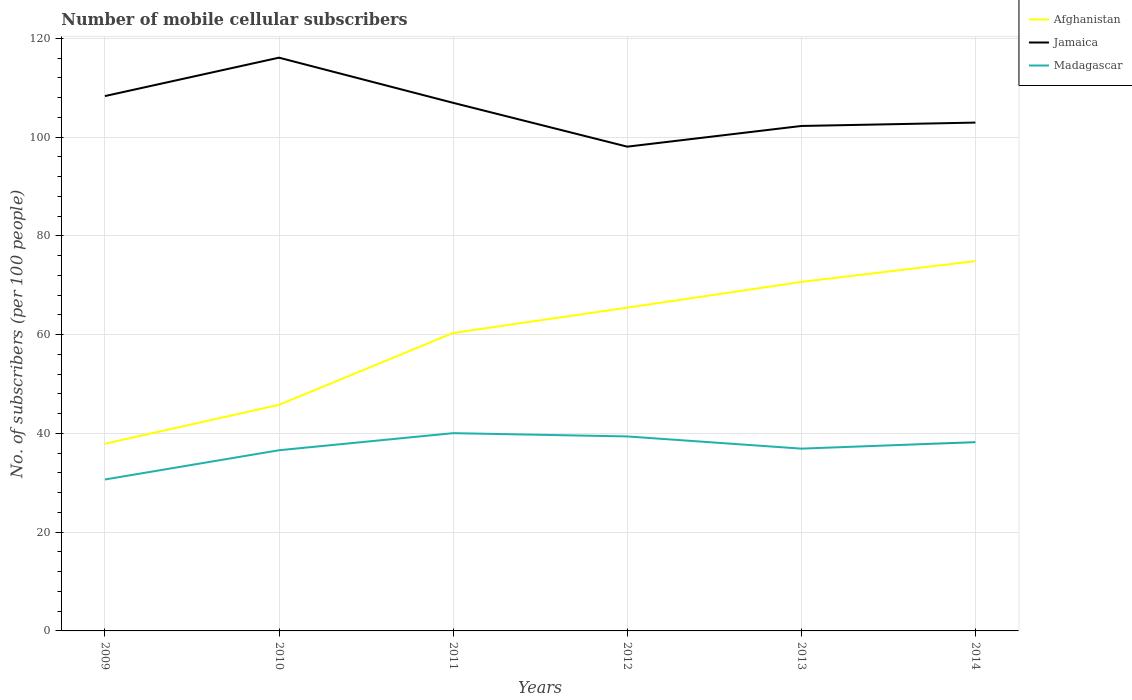Across all years, what is the maximum number of mobile cellular subscribers in Afghanistan?
Give a very brief answer. 37.89. What is the total number of mobile cellular subscribers in Madagascar in the graph?
Offer a very short reply. 3.13. What is the difference between the highest and the second highest number of mobile cellular subscribers in Madagascar?
Your answer should be very brief. 9.38. What is the difference between the highest and the lowest number of mobile cellular subscribers in Madagascar?
Offer a terse response. 3. What is the difference between two consecutive major ticks on the Y-axis?
Provide a short and direct response. 20. Are the values on the major ticks of Y-axis written in scientific E-notation?
Your answer should be very brief. No. Does the graph contain any zero values?
Give a very brief answer. No. Where does the legend appear in the graph?
Give a very brief answer. Top right. How many legend labels are there?
Give a very brief answer. 3. How are the legend labels stacked?
Provide a short and direct response. Vertical. What is the title of the graph?
Your response must be concise. Number of mobile cellular subscribers. What is the label or title of the X-axis?
Provide a succinct answer. Years. What is the label or title of the Y-axis?
Give a very brief answer. No. of subscribers (per 100 people). What is the No. of subscribers (per 100 people) of Afghanistan in 2009?
Offer a very short reply. 37.89. What is the No. of subscribers (per 100 people) of Jamaica in 2009?
Provide a succinct answer. 108.29. What is the No. of subscribers (per 100 people) in Madagascar in 2009?
Your answer should be compact. 30.66. What is the No. of subscribers (per 100 people) in Afghanistan in 2010?
Give a very brief answer. 45.78. What is the No. of subscribers (per 100 people) of Jamaica in 2010?
Your answer should be very brief. 116.07. What is the No. of subscribers (per 100 people) in Madagascar in 2010?
Your response must be concise. 36.58. What is the No. of subscribers (per 100 people) in Afghanistan in 2011?
Provide a succinct answer. 60.33. What is the No. of subscribers (per 100 people) of Jamaica in 2011?
Keep it short and to the point. 106.92. What is the No. of subscribers (per 100 people) of Madagascar in 2011?
Your answer should be very brief. 40.04. What is the No. of subscribers (per 100 people) of Afghanistan in 2012?
Keep it short and to the point. 65.45. What is the No. of subscribers (per 100 people) of Jamaica in 2012?
Make the answer very short. 98.05. What is the No. of subscribers (per 100 people) of Madagascar in 2012?
Provide a short and direct response. 39.38. What is the No. of subscribers (per 100 people) of Afghanistan in 2013?
Give a very brief answer. 70.66. What is the No. of subscribers (per 100 people) of Jamaica in 2013?
Give a very brief answer. 102.24. What is the No. of subscribers (per 100 people) of Madagascar in 2013?
Offer a very short reply. 36.91. What is the No. of subscribers (per 100 people) in Afghanistan in 2014?
Offer a very short reply. 74.88. What is the No. of subscribers (per 100 people) in Jamaica in 2014?
Offer a very short reply. 102.92. What is the No. of subscribers (per 100 people) of Madagascar in 2014?
Your answer should be very brief. 38.22. Across all years, what is the maximum No. of subscribers (per 100 people) in Afghanistan?
Keep it short and to the point. 74.88. Across all years, what is the maximum No. of subscribers (per 100 people) in Jamaica?
Provide a short and direct response. 116.07. Across all years, what is the maximum No. of subscribers (per 100 people) in Madagascar?
Make the answer very short. 40.04. Across all years, what is the minimum No. of subscribers (per 100 people) in Afghanistan?
Your answer should be very brief. 37.89. Across all years, what is the minimum No. of subscribers (per 100 people) of Jamaica?
Make the answer very short. 98.05. Across all years, what is the minimum No. of subscribers (per 100 people) in Madagascar?
Offer a terse response. 30.66. What is the total No. of subscribers (per 100 people) in Afghanistan in the graph?
Keep it short and to the point. 355. What is the total No. of subscribers (per 100 people) of Jamaica in the graph?
Provide a succinct answer. 634.49. What is the total No. of subscribers (per 100 people) in Madagascar in the graph?
Your answer should be compact. 221.79. What is the difference between the No. of subscribers (per 100 people) in Afghanistan in 2009 and that in 2010?
Make the answer very short. -7.88. What is the difference between the No. of subscribers (per 100 people) of Jamaica in 2009 and that in 2010?
Keep it short and to the point. -7.77. What is the difference between the No. of subscribers (per 100 people) of Madagascar in 2009 and that in 2010?
Offer a very short reply. -5.92. What is the difference between the No. of subscribers (per 100 people) in Afghanistan in 2009 and that in 2011?
Provide a succinct answer. -22.43. What is the difference between the No. of subscribers (per 100 people) of Jamaica in 2009 and that in 2011?
Your response must be concise. 1.37. What is the difference between the No. of subscribers (per 100 people) in Madagascar in 2009 and that in 2011?
Your answer should be very brief. -9.38. What is the difference between the No. of subscribers (per 100 people) in Afghanistan in 2009 and that in 2012?
Keep it short and to the point. -27.56. What is the difference between the No. of subscribers (per 100 people) of Jamaica in 2009 and that in 2012?
Keep it short and to the point. 10.24. What is the difference between the No. of subscribers (per 100 people) in Madagascar in 2009 and that in 2012?
Your answer should be very brief. -8.72. What is the difference between the No. of subscribers (per 100 people) of Afghanistan in 2009 and that in 2013?
Your answer should be compact. -32.77. What is the difference between the No. of subscribers (per 100 people) of Jamaica in 2009 and that in 2013?
Keep it short and to the point. 6.06. What is the difference between the No. of subscribers (per 100 people) in Madagascar in 2009 and that in 2013?
Offer a very short reply. -6.25. What is the difference between the No. of subscribers (per 100 people) in Afghanistan in 2009 and that in 2014?
Keep it short and to the point. -36.99. What is the difference between the No. of subscribers (per 100 people) in Jamaica in 2009 and that in 2014?
Provide a succinct answer. 5.37. What is the difference between the No. of subscribers (per 100 people) in Madagascar in 2009 and that in 2014?
Keep it short and to the point. -7.56. What is the difference between the No. of subscribers (per 100 people) of Afghanistan in 2010 and that in 2011?
Your response must be concise. -14.55. What is the difference between the No. of subscribers (per 100 people) in Jamaica in 2010 and that in 2011?
Ensure brevity in your answer.  9.14. What is the difference between the No. of subscribers (per 100 people) in Madagascar in 2010 and that in 2011?
Give a very brief answer. -3.46. What is the difference between the No. of subscribers (per 100 people) in Afghanistan in 2010 and that in 2012?
Offer a terse response. -19.67. What is the difference between the No. of subscribers (per 100 people) in Jamaica in 2010 and that in 2012?
Give a very brief answer. 18.02. What is the difference between the No. of subscribers (per 100 people) of Madagascar in 2010 and that in 2012?
Provide a succinct answer. -2.79. What is the difference between the No. of subscribers (per 100 people) in Afghanistan in 2010 and that in 2013?
Keep it short and to the point. -24.88. What is the difference between the No. of subscribers (per 100 people) in Jamaica in 2010 and that in 2013?
Make the answer very short. 13.83. What is the difference between the No. of subscribers (per 100 people) of Madagascar in 2010 and that in 2013?
Provide a short and direct response. -0.32. What is the difference between the No. of subscribers (per 100 people) of Afghanistan in 2010 and that in 2014?
Offer a terse response. -29.1. What is the difference between the No. of subscribers (per 100 people) in Jamaica in 2010 and that in 2014?
Your answer should be very brief. 13.15. What is the difference between the No. of subscribers (per 100 people) of Madagascar in 2010 and that in 2014?
Your response must be concise. -1.64. What is the difference between the No. of subscribers (per 100 people) of Afghanistan in 2011 and that in 2012?
Give a very brief answer. -5.13. What is the difference between the No. of subscribers (per 100 people) of Jamaica in 2011 and that in 2012?
Your answer should be compact. 8.87. What is the difference between the No. of subscribers (per 100 people) of Madagascar in 2011 and that in 2012?
Your response must be concise. 0.67. What is the difference between the No. of subscribers (per 100 people) of Afghanistan in 2011 and that in 2013?
Make the answer very short. -10.34. What is the difference between the No. of subscribers (per 100 people) in Jamaica in 2011 and that in 2013?
Offer a terse response. 4.69. What is the difference between the No. of subscribers (per 100 people) of Madagascar in 2011 and that in 2013?
Ensure brevity in your answer.  3.13. What is the difference between the No. of subscribers (per 100 people) in Afghanistan in 2011 and that in 2014?
Your answer should be compact. -14.56. What is the difference between the No. of subscribers (per 100 people) of Jamaica in 2011 and that in 2014?
Your answer should be very brief. 4. What is the difference between the No. of subscribers (per 100 people) of Madagascar in 2011 and that in 2014?
Provide a succinct answer. 1.82. What is the difference between the No. of subscribers (per 100 people) in Afghanistan in 2012 and that in 2013?
Offer a terse response. -5.21. What is the difference between the No. of subscribers (per 100 people) in Jamaica in 2012 and that in 2013?
Give a very brief answer. -4.19. What is the difference between the No. of subscribers (per 100 people) of Madagascar in 2012 and that in 2013?
Your response must be concise. 2.47. What is the difference between the No. of subscribers (per 100 people) in Afghanistan in 2012 and that in 2014?
Your answer should be compact. -9.43. What is the difference between the No. of subscribers (per 100 people) of Jamaica in 2012 and that in 2014?
Your answer should be very brief. -4.87. What is the difference between the No. of subscribers (per 100 people) of Madagascar in 2012 and that in 2014?
Offer a very short reply. 1.16. What is the difference between the No. of subscribers (per 100 people) of Afghanistan in 2013 and that in 2014?
Your answer should be very brief. -4.22. What is the difference between the No. of subscribers (per 100 people) of Jamaica in 2013 and that in 2014?
Keep it short and to the point. -0.68. What is the difference between the No. of subscribers (per 100 people) in Madagascar in 2013 and that in 2014?
Offer a terse response. -1.31. What is the difference between the No. of subscribers (per 100 people) of Afghanistan in 2009 and the No. of subscribers (per 100 people) of Jamaica in 2010?
Keep it short and to the point. -78.17. What is the difference between the No. of subscribers (per 100 people) of Afghanistan in 2009 and the No. of subscribers (per 100 people) of Madagascar in 2010?
Offer a very short reply. 1.31. What is the difference between the No. of subscribers (per 100 people) in Jamaica in 2009 and the No. of subscribers (per 100 people) in Madagascar in 2010?
Offer a very short reply. 71.71. What is the difference between the No. of subscribers (per 100 people) of Afghanistan in 2009 and the No. of subscribers (per 100 people) of Jamaica in 2011?
Your answer should be compact. -69.03. What is the difference between the No. of subscribers (per 100 people) of Afghanistan in 2009 and the No. of subscribers (per 100 people) of Madagascar in 2011?
Keep it short and to the point. -2.15. What is the difference between the No. of subscribers (per 100 people) in Jamaica in 2009 and the No. of subscribers (per 100 people) in Madagascar in 2011?
Keep it short and to the point. 68.25. What is the difference between the No. of subscribers (per 100 people) in Afghanistan in 2009 and the No. of subscribers (per 100 people) in Jamaica in 2012?
Keep it short and to the point. -60.15. What is the difference between the No. of subscribers (per 100 people) in Afghanistan in 2009 and the No. of subscribers (per 100 people) in Madagascar in 2012?
Your response must be concise. -1.48. What is the difference between the No. of subscribers (per 100 people) in Jamaica in 2009 and the No. of subscribers (per 100 people) in Madagascar in 2012?
Provide a succinct answer. 68.92. What is the difference between the No. of subscribers (per 100 people) of Afghanistan in 2009 and the No. of subscribers (per 100 people) of Jamaica in 2013?
Your answer should be compact. -64.34. What is the difference between the No. of subscribers (per 100 people) of Afghanistan in 2009 and the No. of subscribers (per 100 people) of Madagascar in 2013?
Your response must be concise. 0.99. What is the difference between the No. of subscribers (per 100 people) of Jamaica in 2009 and the No. of subscribers (per 100 people) of Madagascar in 2013?
Give a very brief answer. 71.39. What is the difference between the No. of subscribers (per 100 people) in Afghanistan in 2009 and the No. of subscribers (per 100 people) in Jamaica in 2014?
Offer a very short reply. -65.03. What is the difference between the No. of subscribers (per 100 people) in Afghanistan in 2009 and the No. of subscribers (per 100 people) in Madagascar in 2014?
Offer a very short reply. -0.32. What is the difference between the No. of subscribers (per 100 people) in Jamaica in 2009 and the No. of subscribers (per 100 people) in Madagascar in 2014?
Your answer should be very brief. 70.08. What is the difference between the No. of subscribers (per 100 people) in Afghanistan in 2010 and the No. of subscribers (per 100 people) in Jamaica in 2011?
Ensure brevity in your answer.  -61.15. What is the difference between the No. of subscribers (per 100 people) of Afghanistan in 2010 and the No. of subscribers (per 100 people) of Madagascar in 2011?
Your response must be concise. 5.74. What is the difference between the No. of subscribers (per 100 people) in Jamaica in 2010 and the No. of subscribers (per 100 people) in Madagascar in 2011?
Ensure brevity in your answer.  76.03. What is the difference between the No. of subscribers (per 100 people) of Afghanistan in 2010 and the No. of subscribers (per 100 people) of Jamaica in 2012?
Offer a terse response. -52.27. What is the difference between the No. of subscribers (per 100 people) in Afghanistan in 2010 and the No. of subscribers (per 100 people) in Madagascar in 2012?
Provide a short and direct response. 6.4. What is the difference between the No. of subscribers (per 100 people) of Jamaica in 2010 and the No. of subscribers (per 100 people) of Madagascar in 2012?
Give a very brief answer. 76.69. What is the difference between the No. of subscribers (per 100 people) of Afghanistan in 2010 and the No. of subscribers (per 100 people) of Jamaica in 2013?
Give a very brief answer. -56.46. What is the difference between the No. of subscribers (per 100 people) of Afghanistan in 2010 and the No. of subscribers (per 100 people) of Madagascar in 2013?
Your answer should be compact. 8.87. What is the difference between the No. of subscribers (per 100 people) of Jamaica in 2010 and the No. of subscribers (per 100 people) of Madagascar in 2013?
Ensure brevity in your answer.  79.16. What is the difference between the No. of subscribers (per 100 people) in Afghanistan in 2010 and the No. of subscribers (per 100 people) in Jamaica in 2014?
Ensure brevity in your answer.  -57.14. What is the difference between the No. of subscribers (per 100 people) of Afghanistan in 2010 and the No. of subscribers (per 100 people) of Madagascar in 2014?
Keep it short and to the point. 7.56. What is the difference between the No. of subscribers (per 100 people) of Jamaica in 2010 and the No. of subscribers (per 100 people) of Madagascar in 2014?
Keep it short and to the point. 77.85. What is the difference between the No. of subscribers (per 100 people) of Afghanistan in 2011 and the No. of subscribers (per 100 people) of Jamaica in 2012?
Give a very brief answer. -37.72. What is the difference between the No. of subscribers (per 100 people) in Afghanistan in 2011 and the No. of subscribers (per 100 people) in Madagascar in 2012?
Offer a terse response. 20.95. What is the difference between the No. of subscribers (per 100 people) of Jamaica in 2011 and the No. of subscribers (per 100 people) of Madagascar in 2012?
Your response must be concise. 67.55. What is the difference between the No. of subscribers (per 100 people) of Afghanistan in 2011 and the No. of subscribers (per 100 people) of Jamaica in 2013?
Offer a very short reply. -41.91. What is the difference between the No. of subscribers (per 100 people) in Afghanistan in 2011 and the No. of subscribers (per 100 people) in Madagascar in 2013?
Provide a succinct answer. 23.42. What is the difference between the No. of subscribers (per 100 people) in Jamaica in 2011 and the No. of subscribers (per 100 people) in Madagascar in 2013?
Your answer should be compact. 70.02. What is the difference between the No. of subscribers (per 100 people) in Afghanistan in 2011 and the No. of subscribers (per 100 people) in Jamaica in 2014?
Make the answer very short. -42.59. What is the difference between the No. of subscribers (per 100 people) in Afghanistan in 2011 and the No. of subscribers (per 100 people) in Madagascar in 2014?
Offer a very short reply. 22.11. What is the difference between the No. of subscribers (per 100 people) of Jamaica in 2011 and the No. of subscribers (per 100 people) of Madagascar in 2014?
Offer a terse response. 68.7. What is the difference between the No. of subscribers (per 100 people) of Afghanistan in 2012 and the No. of subscribers (per 100 people) of Jamaica in 2013?
Your answer should be compact. -36.79. What is the difference between the No. of subscribers (per 100 people) in Afghanistan in 2012 and the No. of subscribers (per 100 people) in Madagascar in 2013?
Ensure brevity in your answer.  28.54. What is the difference between the No. of subscribers (per 100 people) in Jamaica in 2012 and the No. of subscribers (per 100 people) in Madagascar in 2013?
Your answer should be compact. 61.14. What is the difference between the No. of subscribers (per 100 people) of Afghanistan in 2012 and the No. of subscribers (per 100 people) of Jamaica in 2014?
Give a very brief answer. -37.47. What is the difference between the No. of subscribers (per 100 people) of Afghanistan in 2012 and the No. of subscribers (per 100 people) of Madagascar in 2014?
Ensure brevity in your answer.  27.23. What is the difference between the No. of subscribers (per 100 people) in Jamaica in 2012 and the No. of subscribers (per 100 people) in Madagascar in 2014?
Provide a succinct answer. 59.83. What is the difference between the No. of subscribers (per 100 people) in Afghanistan in 2013 and the No. of subscribers (per 100 people) in Jamaica in 2014?
Keep it short and to the point. -32.26. What is the difference between the No. of subscribers (per 100 people) in Afghanistan in 2013 and the No. of subscribers (per 100 people) in Madagascar in 2014?
Offer a very short reply. 32.44. What is the difference between the No. of subscribers (per 100 people) of Jamaica in 2013 and the No. of subscribers (per 100 people) of Madagascar in 2014?
Your response must be concise. 64.02. What is the average No. of subscribers (per 100 people) of Afghanistan per year?
Keep it short and to the point. 59.17. What is the average No. of subscribers (per 100 people) in Jamaica per year?
Give a very brief answer. 105.75. What is the average No. of subscribers (per 100 people) of Madagascar per year?
Ensure brevity in your answer.  36.96. In the year 2009, what is the difference between the No. of subscribers (per 100 people) in Afghanistan and No. of subscribers (per 100 people) in Jamaica?
Offer a very short reply. -70.4. In the year 2009, what is the difference between the No. of subscribers (per 100 people) of Afghanistan and No. of subscribers (per 100 people) of Madagascar?
Keep it short and to the point. 7.24. In the year 2009, what is the difference between the No. of subscribers (per 100 people) in Jamaica and No. of subscribers (per 100 people) in Madagascar?
Offer a very short reply. 77.64. In the year 2010, what is the difference between the No. of subscribers (per 100 people) in Afghanistan and No. of subscribers (per 100 people) in Jamaica?
Ensure brevity in your answer.  -70.29. In the year 2010, what is the difference between the No. of subscribers (per 100 people) in Afghanistan and No. of subscribers (per 100 people) in Madagascar?
Offer a very short reply. 9.19. In the year 2010, what is the difference between the No. of subscribers (per 100 people) of Jamaica and No. of subscribers (per 100 people) of Madagascar?
Provide a short and direct response. 79.48. In the year 2011, what is the difference between the No. of subscribers (per 100 people) in Afghanistan and No. of subscribers (per 100 people) in Jamaica?
Give a very brief answer. -46.6. In the year 2011, what is the difference between the No. of subscribers (per 100 people) of Afghanistan and No. of subscribers (per 100 people) of Madagascar?
Ensure brevity in your answer.  20.28. In the year 2011, what is the difference between the No. of subscribers (per 100 people) in Jamaica and No. of subscribers (per 100 people) in Madagascar?
Give a very brief answer. 66.88. In the year 2012, what is the difference between the No. of subscribers (per 100 people) in Afghanistan and No. of subscribers (per 100 people) in Jamaica?
Provide a succinct answer. -32.6. In the year 2012, what is the difference between the No. of subscribers (per 100 people) in Afghanistan and No. of subscribers (per 100 people) in Madagascar?
Provide a succinct answer. 26.08. In the year 2012, what is the difference between the No. of subscribers (per 100 people) of Jamaica and No. of subscribers (per 100 people) of Madagascar?
Your answer should be compact. 58.67. In the year 2013, what is the difference between the No. of subscribers (per 100 people) in Afghanistan and No. of subscribers (per 100 people) in Jamaica?
Your answer should be very brief. -31.58. In the year 2013, what is the difference between the No. of subscribers (per 100 people) in Afghanistan and No. of subscribers (per 100 people) in Madagascar?
Make the answer very short. 33.75. In the year 2013, what is the difference between the No. of subscribers (per 100 people) in Jamaica and No. of subscribers (per 100 people) in Madagascar?
Ensure brevity in your answer.  65.33. In the year 2014, what is the difference between the No. of subscribers (per 100 people) of Afghanistan and No. of subscribers (per 100 people) of Jamaica?
Ensure brevity in your answer.  -28.04. In the year 2014, what is the difference between the No. of subscribers (per 100 people) of Afghanistan and No. of subscribers (per 100 people) of Madagascar?
Provide a succinct answer. 36.66. In the year 2014, what is the difference between the No. of subscribers (per 100 people) in Jamaica and No. of subscribers (per 100 people) in Madagascar?
Your answer should be very brief. 64.7. What is the ratio of the No. of subscribers (per 100 people) of Afghanistan in 2009 to that in 2010?
Your response must be concise. 0.83. What is the ratio of the No. of subscribers (per 100 people) in Jamaica in 2009 to that in 2010?
Provide a succinct answer. 0.93. What is the ratio of the No. of subscribers (per 100 people) of Madagascar in 2009 to that in 2010?
Provide a succinct answer. 0.84. What is the ratio of the No. of subscribers (per 100 people) of Afghanistan in 2009 to that in 2011?
Keep it short and to the point. 0.63. What is the ratio of the No. of subscribers (per 100 people) in Jamaica in 2009 to that in 2011?
Give a very brief answer. 1.01. What is the ratio of the No. of subscribers (per 100 people) of Madagascar in 2009 to that in 2011?
Your response must be concise. 0.77. What is the ratio of the No. of subscribers (per 100 people) in Afghanistan in 2009 to that in 2012?
Your answer should be very brief. 0.58. What is the ratio of the No. of subscribers (per 100 people) of Jamaica in 2009 to that in 2012?
Your answer should be compact. 1.1. What is the ratio of the No. of subscribers (per 100 people) of Madagascar in 2009 to that in 2012?
Provide a short and direct response. 0.78. What is the ratio of the No. of subscribers (per 100 people) in Afghanistan in 2009 to that in 2013?
Keep it short and to the point. 0.54. What is the ratio of the No. of subscribers (per 100 people) in Jamaica in 2009 to that in 2013?
Make the answer very short. 1.06. What is the ratio of the No. of subscribers (per 100 people) of Madagascar in 2009 to that in 2013?
Give a very brief answer. 0.83. What is the ratio of the No. of subscribers (per 100 people) of Afghanistan in 2009 to that in 2014?
Provide a short and direct response. 0.51. What is the ratio of the No. of subscribers (per 100 people) in Jamaica in 2009 to that in 2014?
Provide a short and direct response. 1.05. What is the ratio of the No. of subscribers (per 100 people) of Madagascar in 2009 to that in 2014?
Your answer should be very brief. 0.8. What is the ratio of the No. of subscribers (per 100 people) of Afghanistan in 2010 to that in 2011?
Offer a very short reply. 0.76. What is the ratio of the No. of subscribers (per 100 people) in Jamaica in 2010 to that in 2011?
Your answer should be very brief. 1.09. What is the ratio of the No. of subscribers (per 100 people) in Madagascar in 2010 to that in 2011?
Offer a very short reply. 0.91. What is the ratio of the No. of subscribers (per 100 people) in Afghanistan in 2010 to that in 2012?
Your response must be concise. 0.7. What is the ratio of the No. of subscribers (per 100 people) of Jamaica in 2010 to that in 2012?
Provide a short and direct response. 1.18. What is the ratio of the No. of subscribers (per 100 people) in Madagascar in 2010 to that in 2012?
Your answer should be very brief. 0.93. What is the ratio of the No. of subscribers (per 100 people) of Afghanistan in 2010 to that in 2013?
Your response must be concise. 0.65. What is the ratio of the No. of subscribers (per 100 people) of Jamaica in 2010 to that in 2013?
Give a very brief answer. 1.14. What is the ratio of the No. of subscribers (per 100 people) in Afghanistan in 2010 to that in 2014?
Your answer should be very brief. 0.61. What is the ratio of the No. of subscribers (per 100 people) in Jamaica in 2010 to that in 2014?
Your response must be concise. 1.13. What is the ratio of the No. of subscribers (per 100 people) in Madagascar in 2010 to that in 2014?
Provide a short and direct response. 0.96. What is the ratio of the No. of subscribers (per 100 people) of Afghanistan in 2011 to that in 2012?
Make the answer very short. 0.92. What is the ratio of the No. of subscribers (per 100 people) in Jamaica in 2011 to that in 2012?
Offer a very short reply. 1.09. What is the ratio of the No. of subscribers (per 100 people) of Madagascar in 2011 to that in 2012?
Your answer should be compact. 1.02. What is the ratio of the No. of subscribers (per 100 people) in Afghanistan in 2011 to that in 2013?
Your answer should be compact. 0.85. What is the ratio of the No. of subscribers (per 100 people) in Jamaica in 2011 to that in 2013?
Give a very brief answer. 1.05. What is the ratio of the No. of subscribers (per 100 people) of Madagascar in 2011 to that in 2013?
Ensure brevity in your answer.  1.08. What is the ratio of the No. of subscribers (per 100 people) of Afghanistan in 2011 to that in 2014?
Ensure brevity in your answer.  0.81. What is the ratio of the No. of subscribers (per 100 people) in Jamaica in 2011 to that in 2014?
Make the answer very short. 1.04. What is the ratio of the No. of subscribers (per 100 people) of Madagascar in 2011 to that in 2014?
Ensure brevity in your answer.  1.05. What is the ratio of the No. of subscribers (per 100 people) in Afghanistan in 2012 to that in 2013?
Ensure brevity in your answer.  0.93. What is the ratio of the No. of subscribers (per 100 people) of Madagascar in 2012 to that in 2013?
Offer a very short reply. 1.07. What is the ratio of the No. of subscribers (per 100 people) of Afghanistan in 2012 to that in 2014?
Provide a succinct answer. 0.87. What is the ratio of the No. of subscribers (per 100 people) of Jamaica in 2012 to that in 2014?
Provide a succinct answer. 0.95. What is the ratio of the No. of subscribers (per 100 people) in Madagascar in 2012 to that in 2014?
Provide a short and direct response. 1.03. What is the ratio of the No. of subscribers (per 100 people) of Afghanistan in 2013 to that in 2014?
Your answer should be very brief. 0.94. What is the ratio of the No. of subscribers (per 100 people) of Madagascar in 2013 to that in 2014?
Your response must be concise. 0.97. What is the difference between the highest and the second highest No. of subscribers (per 100 people) of Afghanistan?
Your response must be concise. 4.22. What is the difference between the highest and the second highest No. of subscribers (per 100 people) in Jamaica?
Make the answer very short. 7.77. What is the difference between the highest and the second highest No. of subscribers (per 100 people) of Madagascar?
Your response must be concise. 0.67. What is the difference between the highest and the lowest No. of subscribers (per 100 people) in Afghanistan?
Your answer should be compact. 36.99. What is the difference between the highest and the lowest No. of subscribers (per 100 people) in Jamaica?
Give a very brief answer. 18.02. What is the difference between the highest and the lowest No. of subscribers (per 100 people) of Madagascar?
Offer a very short reply. 9.38. 